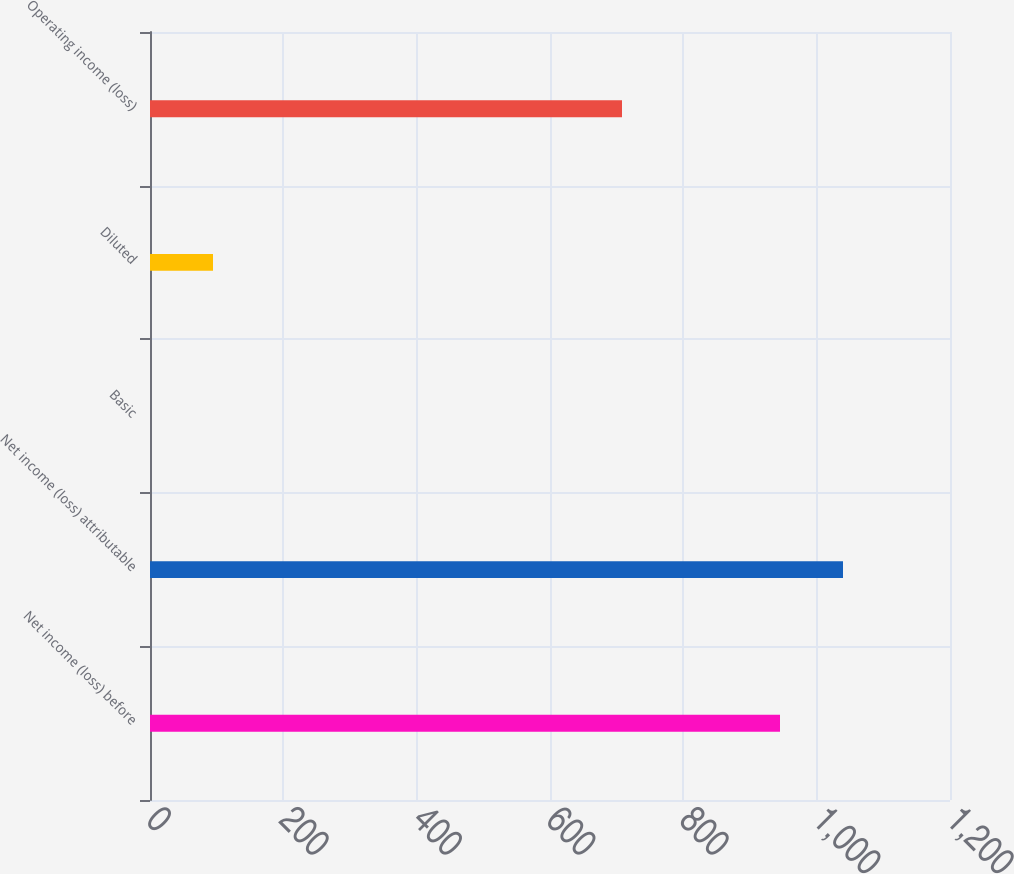Convert chart. <chart><loc_0><loc_0><loc_500><loc_500><bar_chart><fcel>Net income (loss) before<fcel>Net income (loss) attributable<fcel>Basic<fcel>Diluted<fcel>Operating income (loss)<nl><fcel>945<fcel>1039.5<fcel>0.01<fcel>94.51<fcel>708<nl></chart> 